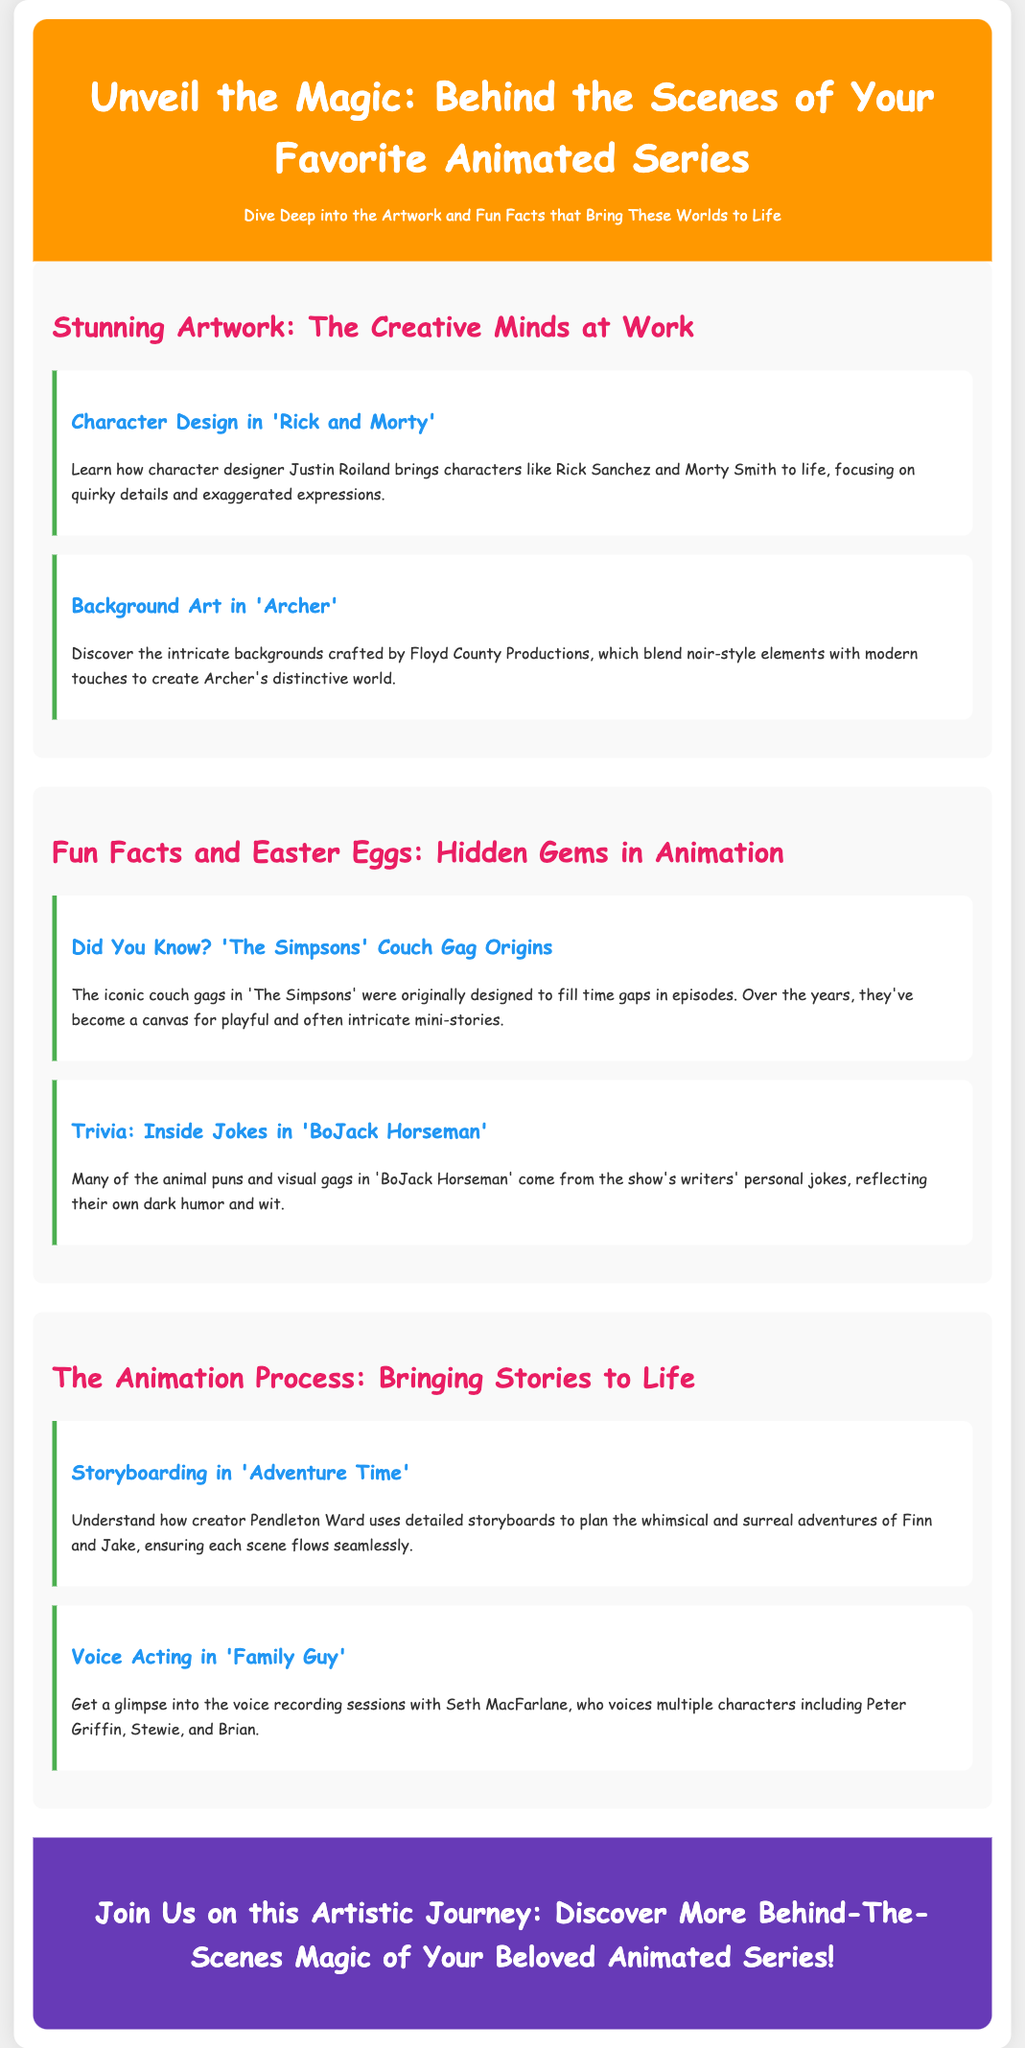What is the title of the advertisement? The title is prominently displayed at the top of the advertisement, providing an overview of the theme of the content.
Answer: Behind the Scenes of Your Favorite Animated Series Who is the character designer for 'Rick and Morty'? The character designer is mentioned in the context of designing iconic characters from the show, specifically highlighting his creativity.
Answer: Justin Roiland What is the background style of 'Archer'? The document specifies the visual elements used in the animated series, indicating the unique aesthetic of its settings.
Answer: Noir-style elements with modern touches What is the origin purpose of 'The Simpsons' couch gags? The advertisement describes a specific characteristic of the show, focusing on the historical context of a popular element within the series.
Answer: To fill time gaps Which character does Seth MacFarlane voice in 'Family Guy'? The document discusses voice acting sessions and identifies specific characters associated with the voice actor.
Answer: Peter Griffin What process does Pendleton Ward use to plan 'Adventure Time'? It highlights a crucial step in the animation process, emphasizing the importance of planning in the storytelling of the series.
Answer: Storyboarding What kind of humor is reflected in 'BoJack Horseman'? The advertisement explains the nature of the humor within the show, relating it to the background and style of the writing team.
Answer: Dark humor What color is the background of the header section? The document describes visual design choices, including color schemes that enhance readability and aesthetics.
Answer: Orange 